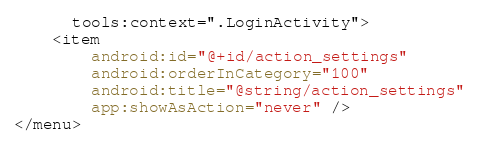Convert code to text. <code><loc_0><loc_0><loc_500><loc_500><_XML_>      tools:context=".LoginActivity">
    <item
        android:id="@+id/action_settings"
        android:orderInCategory="100"
        android:title="@string/action_settings"
        app:showAsAction="never" />
</menu></code> 